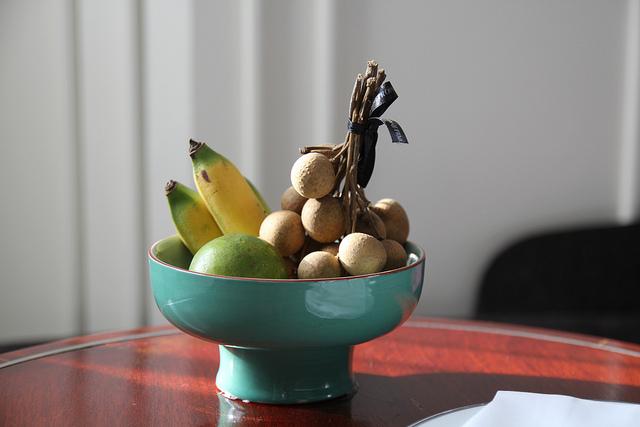Are there grapes in the bowl?
Write a very short answer. No. Is the sunlight direct or filtered?
Quick response, please. Filtered. How many different fruits are in the bowl?
Keep it brief. 3. What color is the base of this item?
Be succinct. Blue. 